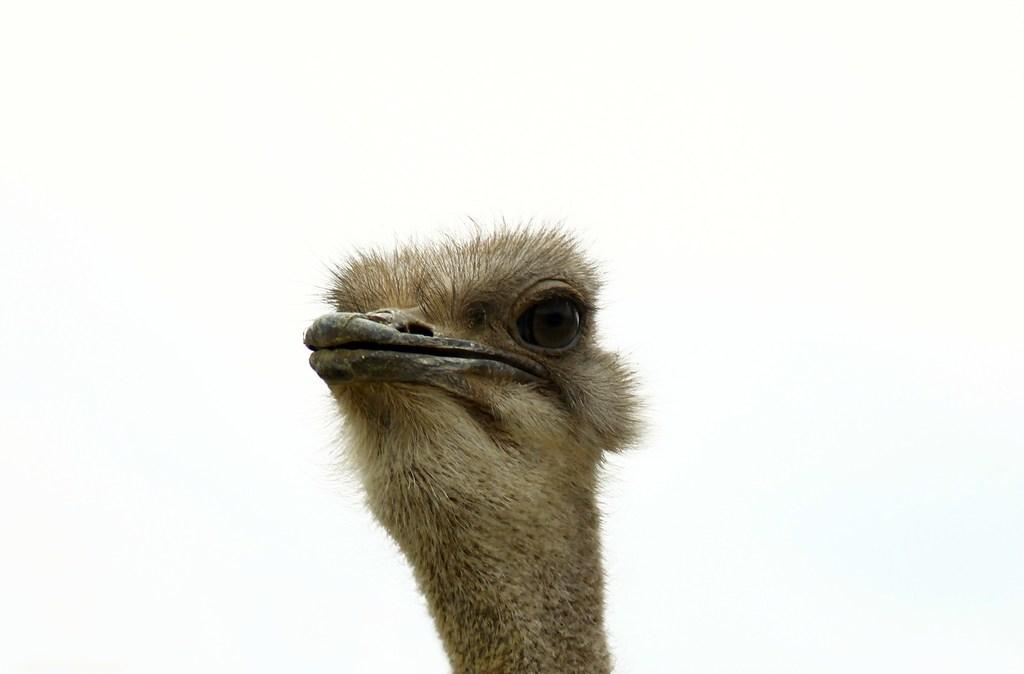What type of animal is in the image? There is an ostrich in the image. What is the color of the ostrich? The ostrich is white in color. What songs can be heard playing in the background of the image? There is no audio or background music present in the image, as it is a still photograph of an ostrich. 